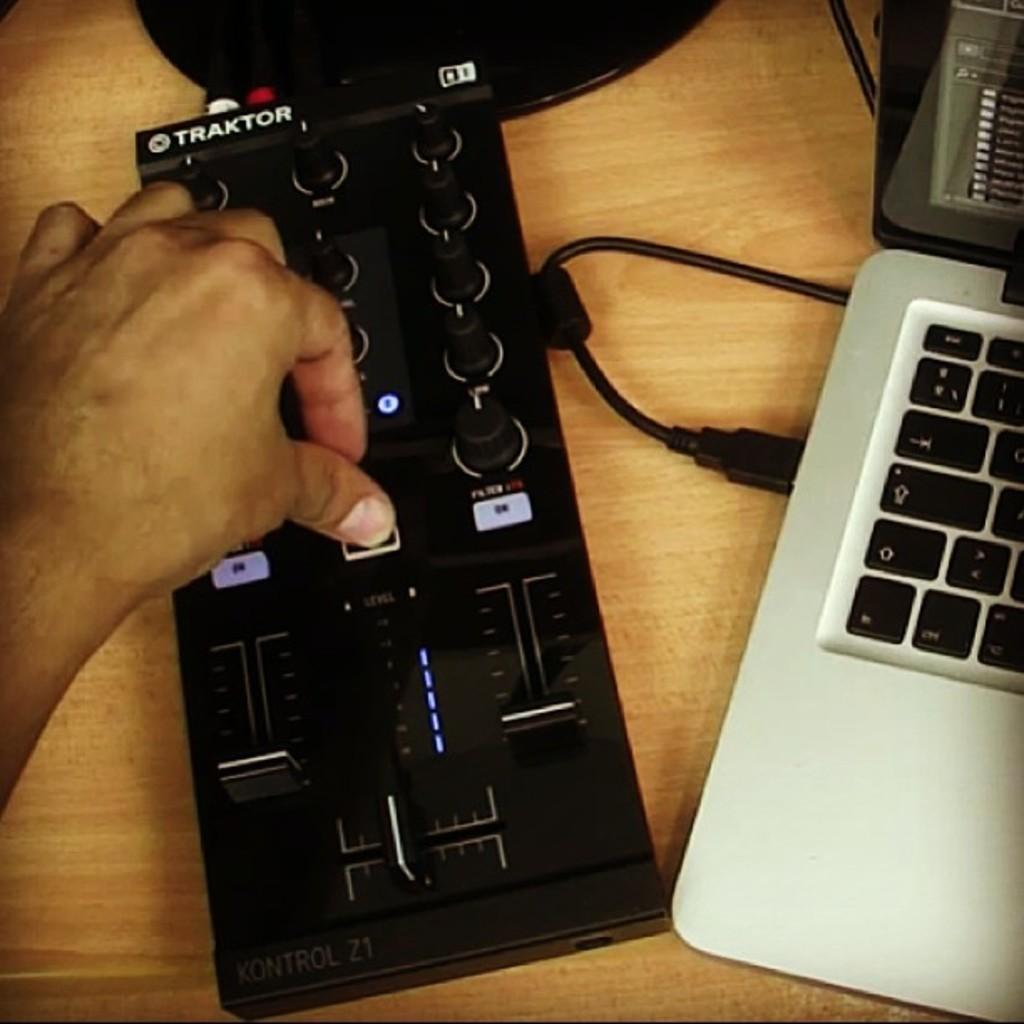<image>
Offer a succinct explanation of the picture presented. A black Traktor controller sitting next to a laptop 